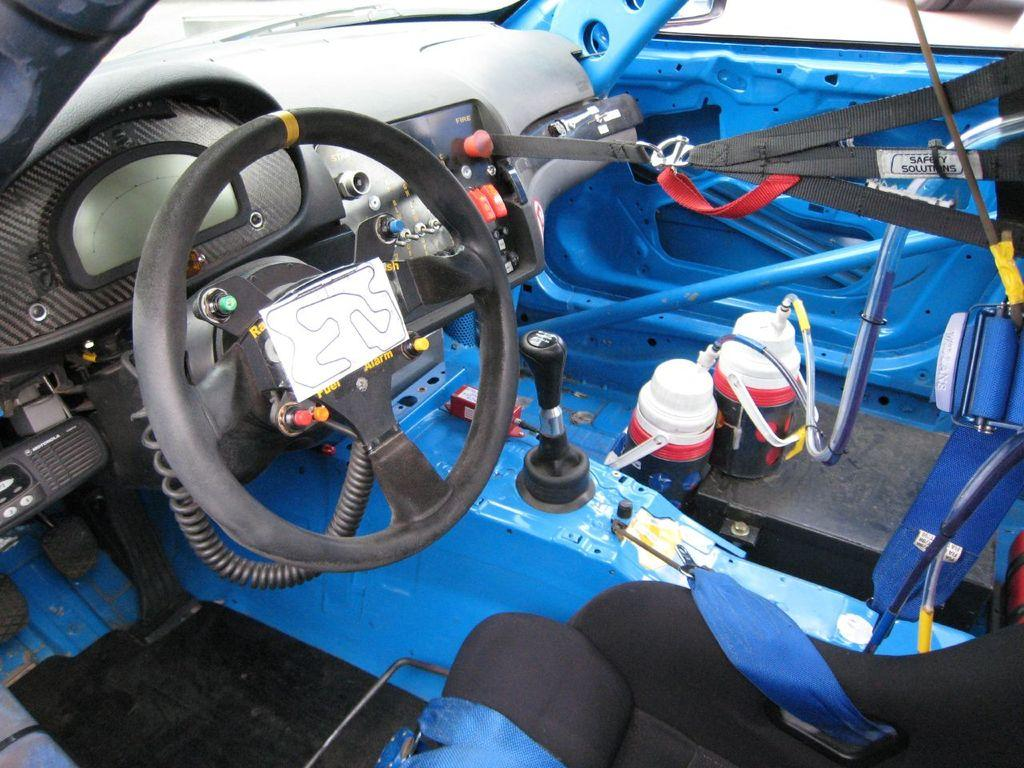What type of setting is depicted in the image? The image shows an interior view of a vehicle. What can be seen inside the vehicle? There are objects inside the vehicle. How much of the vehicle is visible in the image? The vehicle is truncated in the image, meaning only a portion of it is shown. How many tubs are visible in the image? There are no tubs present in the image; it shows an interior view of a vehicle. What type of currency can be seen in the image? There is no currency visible in the image. 